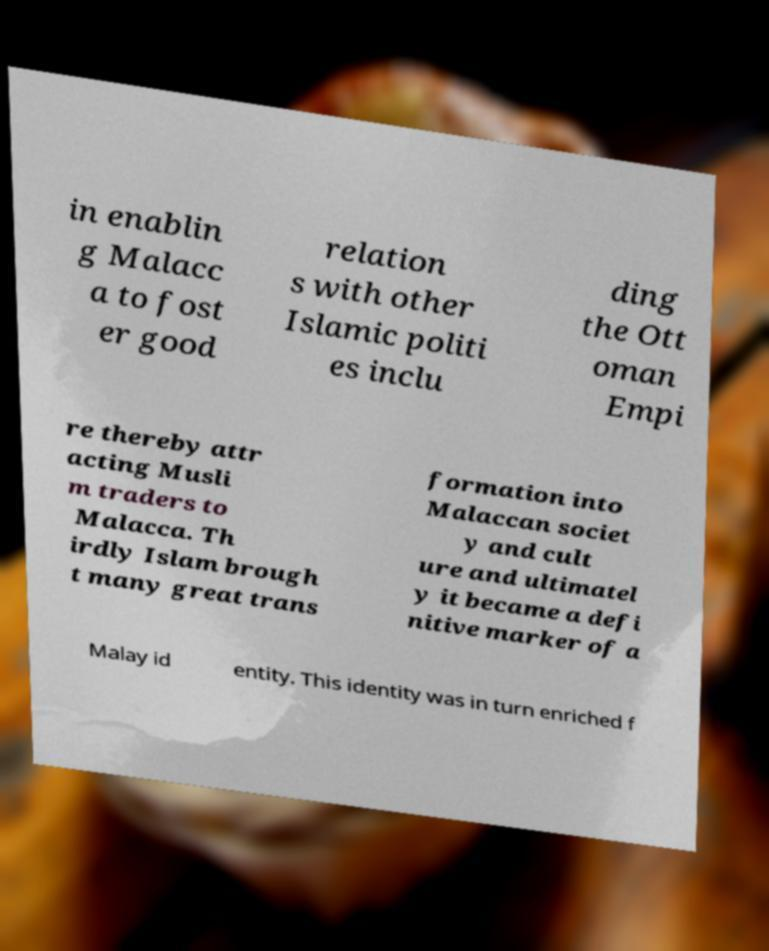For documentation purposes, I need the text within this image transcribed. Could you provide that? in enablin g Malacc a to fost er good relation s with other Islamic politi es inclu ding the Ott oman Empi re thereby attr acting Musli m traders to Malacca. Th irdly Islam brough t many great trans formation into Malaccan societ y and cult ure and ultimatel y it became a defi nitive marker of a Malay id entity. This identity was in turn enriched f 